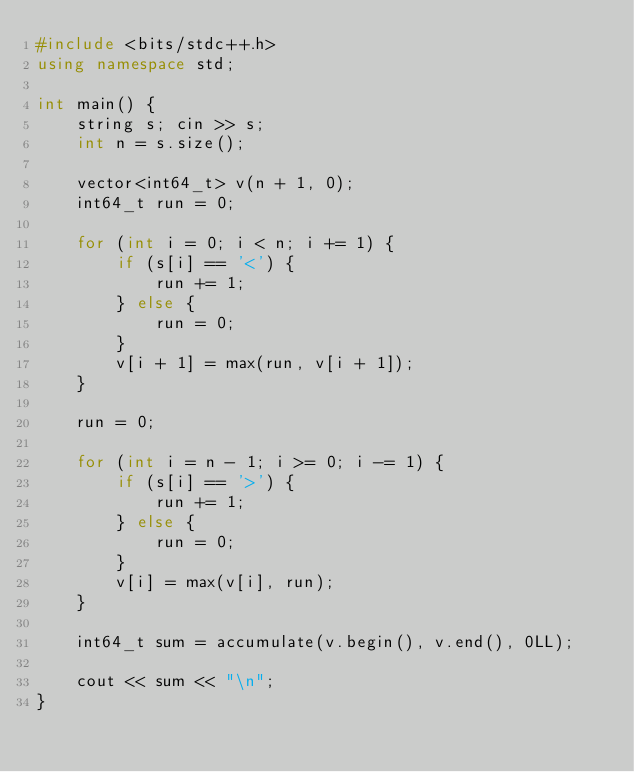<code> <loc_0><loc_0><loc_500><loc_500><_C++_>#include <bits/stdc++.h>
using namespace std;

int main() {
    string s; cin >> s;
    int n = s.size();
        
    vector<int64_t> v(n + 1, 0);
    int64_t run = 0;

    for (int i = 0; i < n; i += 1) {
        if (s[i] == '<') {
            run += 1;
        } else {
            run = 0;
        }
        v[i + 1] = max(run, v[i + 1]);
    }
    
    run = 0;

    for (int i = n - 1; i >= 0; i -= 1) {
        if (s[i] == '>') {
            run += 1;
        } else {
            run = 0;
        }
        v[i] = max(v[i], run);
    }
       
    int64_t sum = accumulate(v.begin(), v.end(), 0LL);

    cout << sum << "\n";
}</code> 